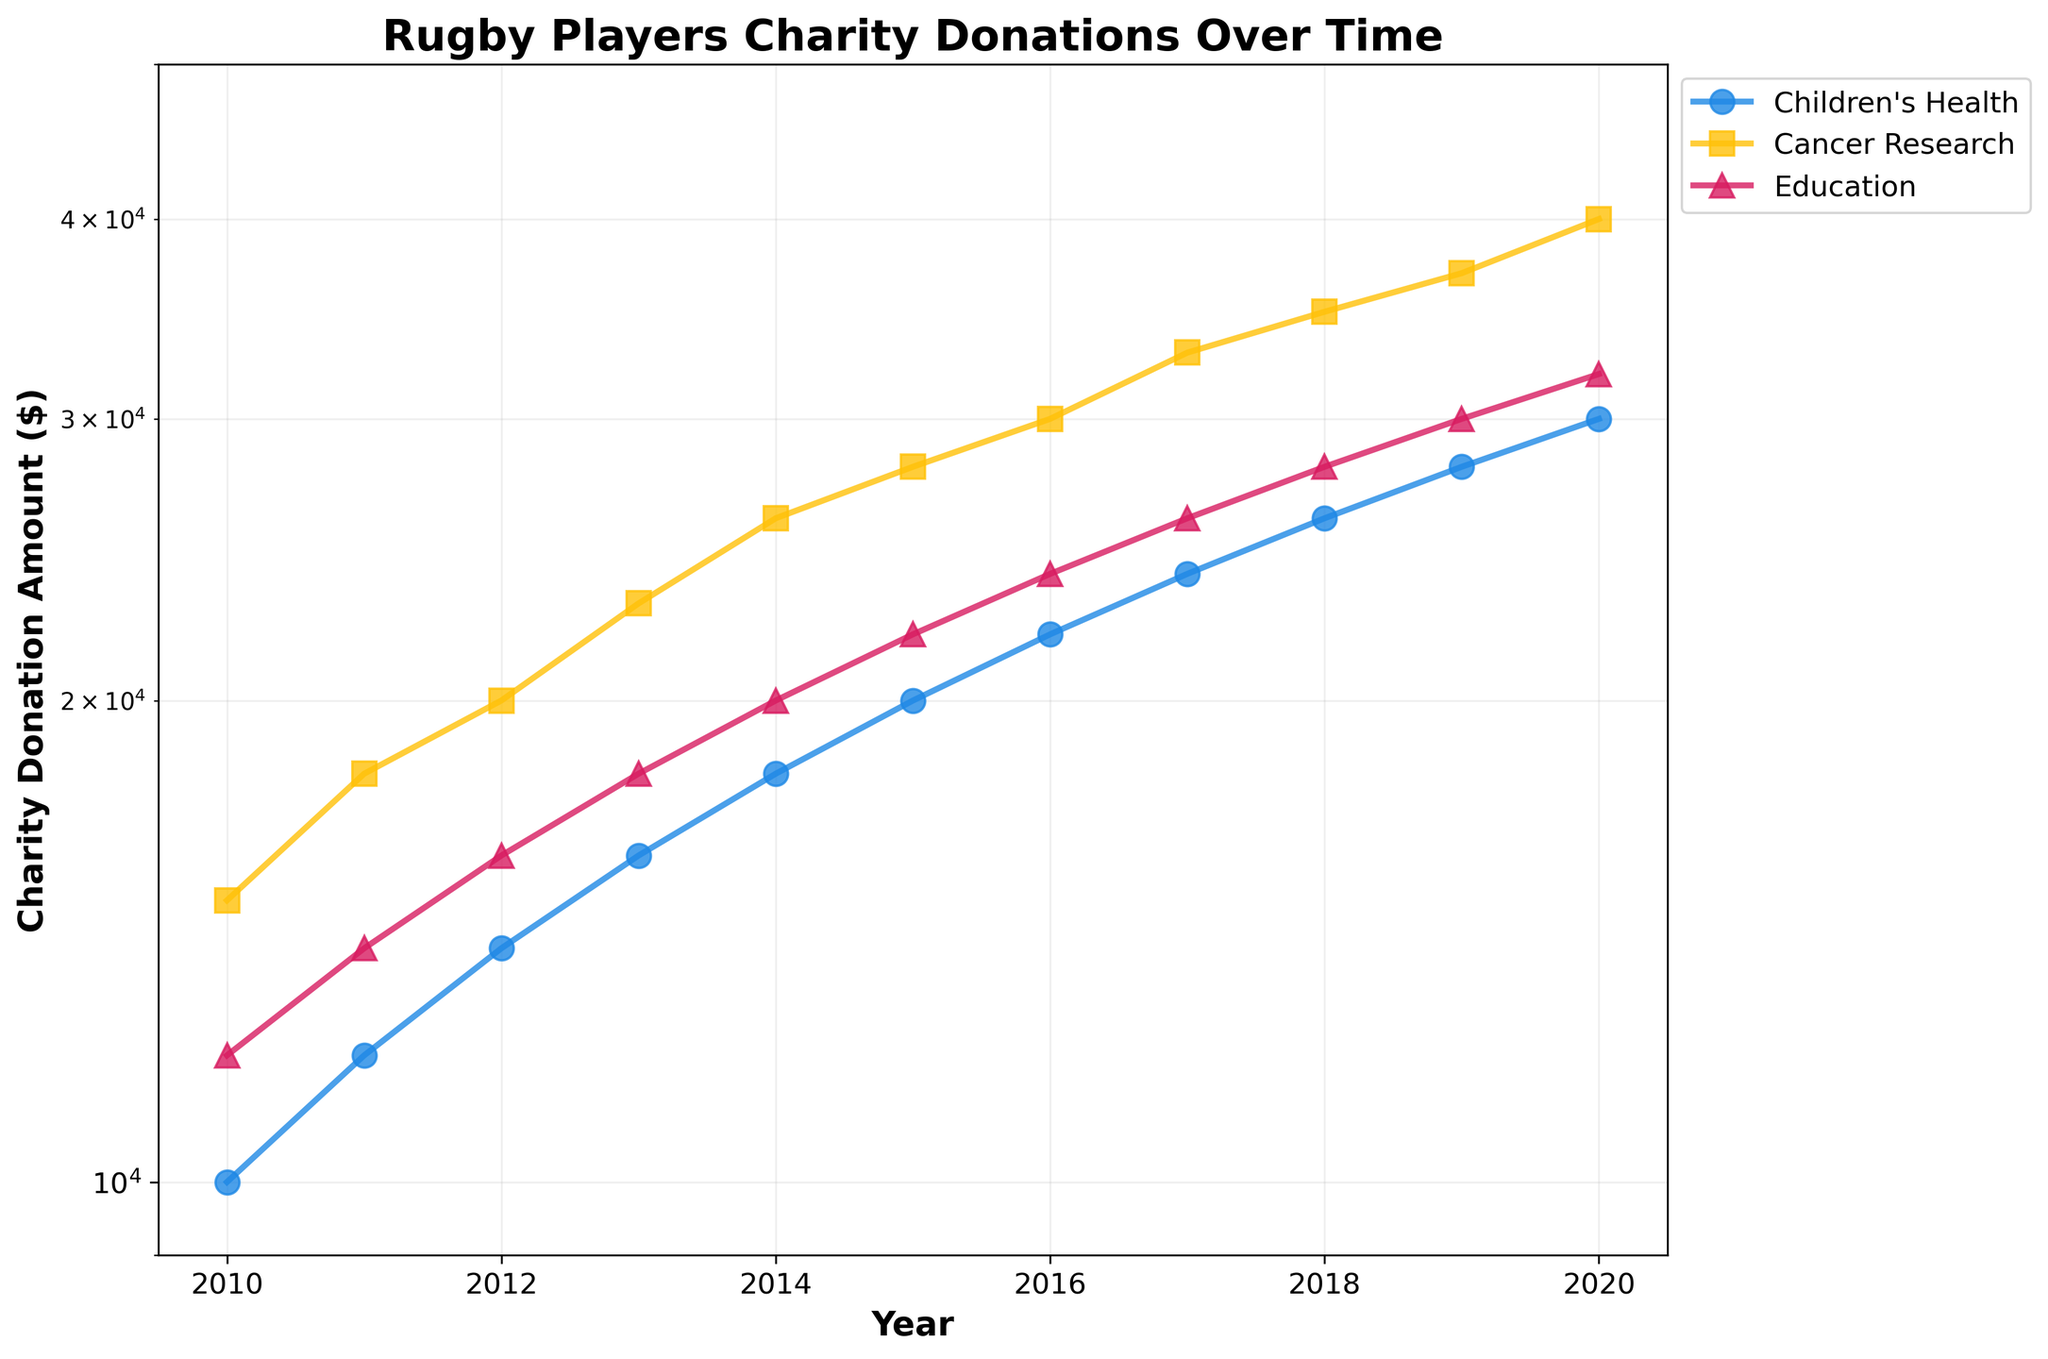What is the title of the figure? The title is usually located at the top of the figure. It provides a concise summary of what the figure represents.
Answer: Rugby Players Charity Donations Over Time Which cause had the highest donation amount in 2020? To find the highest donation amount for a given year, look for that year on the x-axis and observe the corresponding y-axis values for each cause.
Answer: Cancer Research How many causes are displayed in the figure? Each unique color and marker combination represents a different cause. Count the different legends that show up at the top right of the plot.
Answer: 3 What's the donation amount for Children's Health in 2013? Locate the year 2013 on the x-axis, follow it up to the line representing Children's Health (indicated by its unique marker and color), and observe the corresponding y-axis value.
Answer: $16,000 By how much did the donations to Education increase from 2017 to 2018? Identify the donation amounts for Education in both 2017 and 2018 by following their respective x-axis positions to the corresponding y-axis values. Calculate the difference between these two amounts.
Answer: $2,000 Which year shows a 50% increase in donations to Cancer Research compared to the previous year? For each year, compare the Cancer Research donation amount to the previous year's amount. A 50% increase implies the new amount is 1.5 times the old amount.
Answer: 2014 How does the donation trend for Children's Health compare to Cancer Research from 2010 to 2020? Observe the slopes of the lines representing Children's Health and Cancer Research over the years. Check for consistent increases or decreases and steepness.
Answer: Cancer Research increases consistently and more steeply than Children's Health What is the approximate average donation amount for Education between 2010 and 2015? Sum the donation amounts for Education from 2010 to 2015 and divide by the number of years (6).
Answer: $16,333 Which cause shows the most consistent increase over the years? Look for the cause whose line shows a steady upward trend without significant fluctuations.
Answer: Cancer Research 